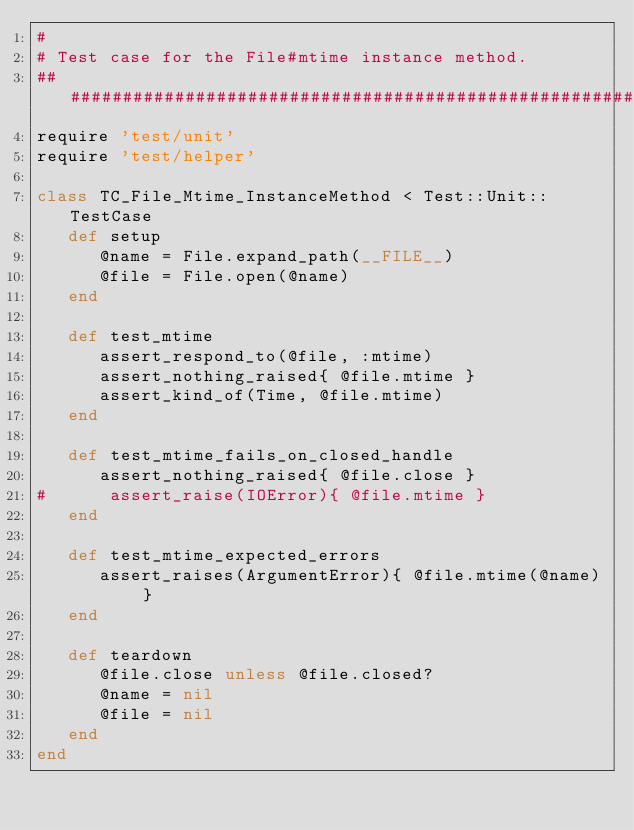<code> <loc_0><loc_0><loc_500><loc_500><_Ruby_>#
# Test case for the File#mtime instance method.
#####################################################################
require 'test/unit'
require 'test/helper'

class TC_File_Mtime_InstanceMethod < Test::Unit::TestCase
   def setup
      @name = File.expand_path(__FILE__)
      @file = File.open(@name)
   end

   def test_mtime
      assert_respond_to(@file, :mtime)
      assert_nothing_raised{ @file.mtime }
      assert_kind_of(Time, @file.mtime)
   end

   def test_mtime_fails_on_closed_handle
      assert_nothing_raised{ @file.close }
#      assert_raise(IOError){ @file.mtime }
   end

   def test_mtime_expected_errors
      assert_raises(ArgumentError){ @file.mtime(@name) }
   end

   def teardown
      @file.close unless @file.closed?
      @name = nil
      @file = nil
   end
end
</code> 